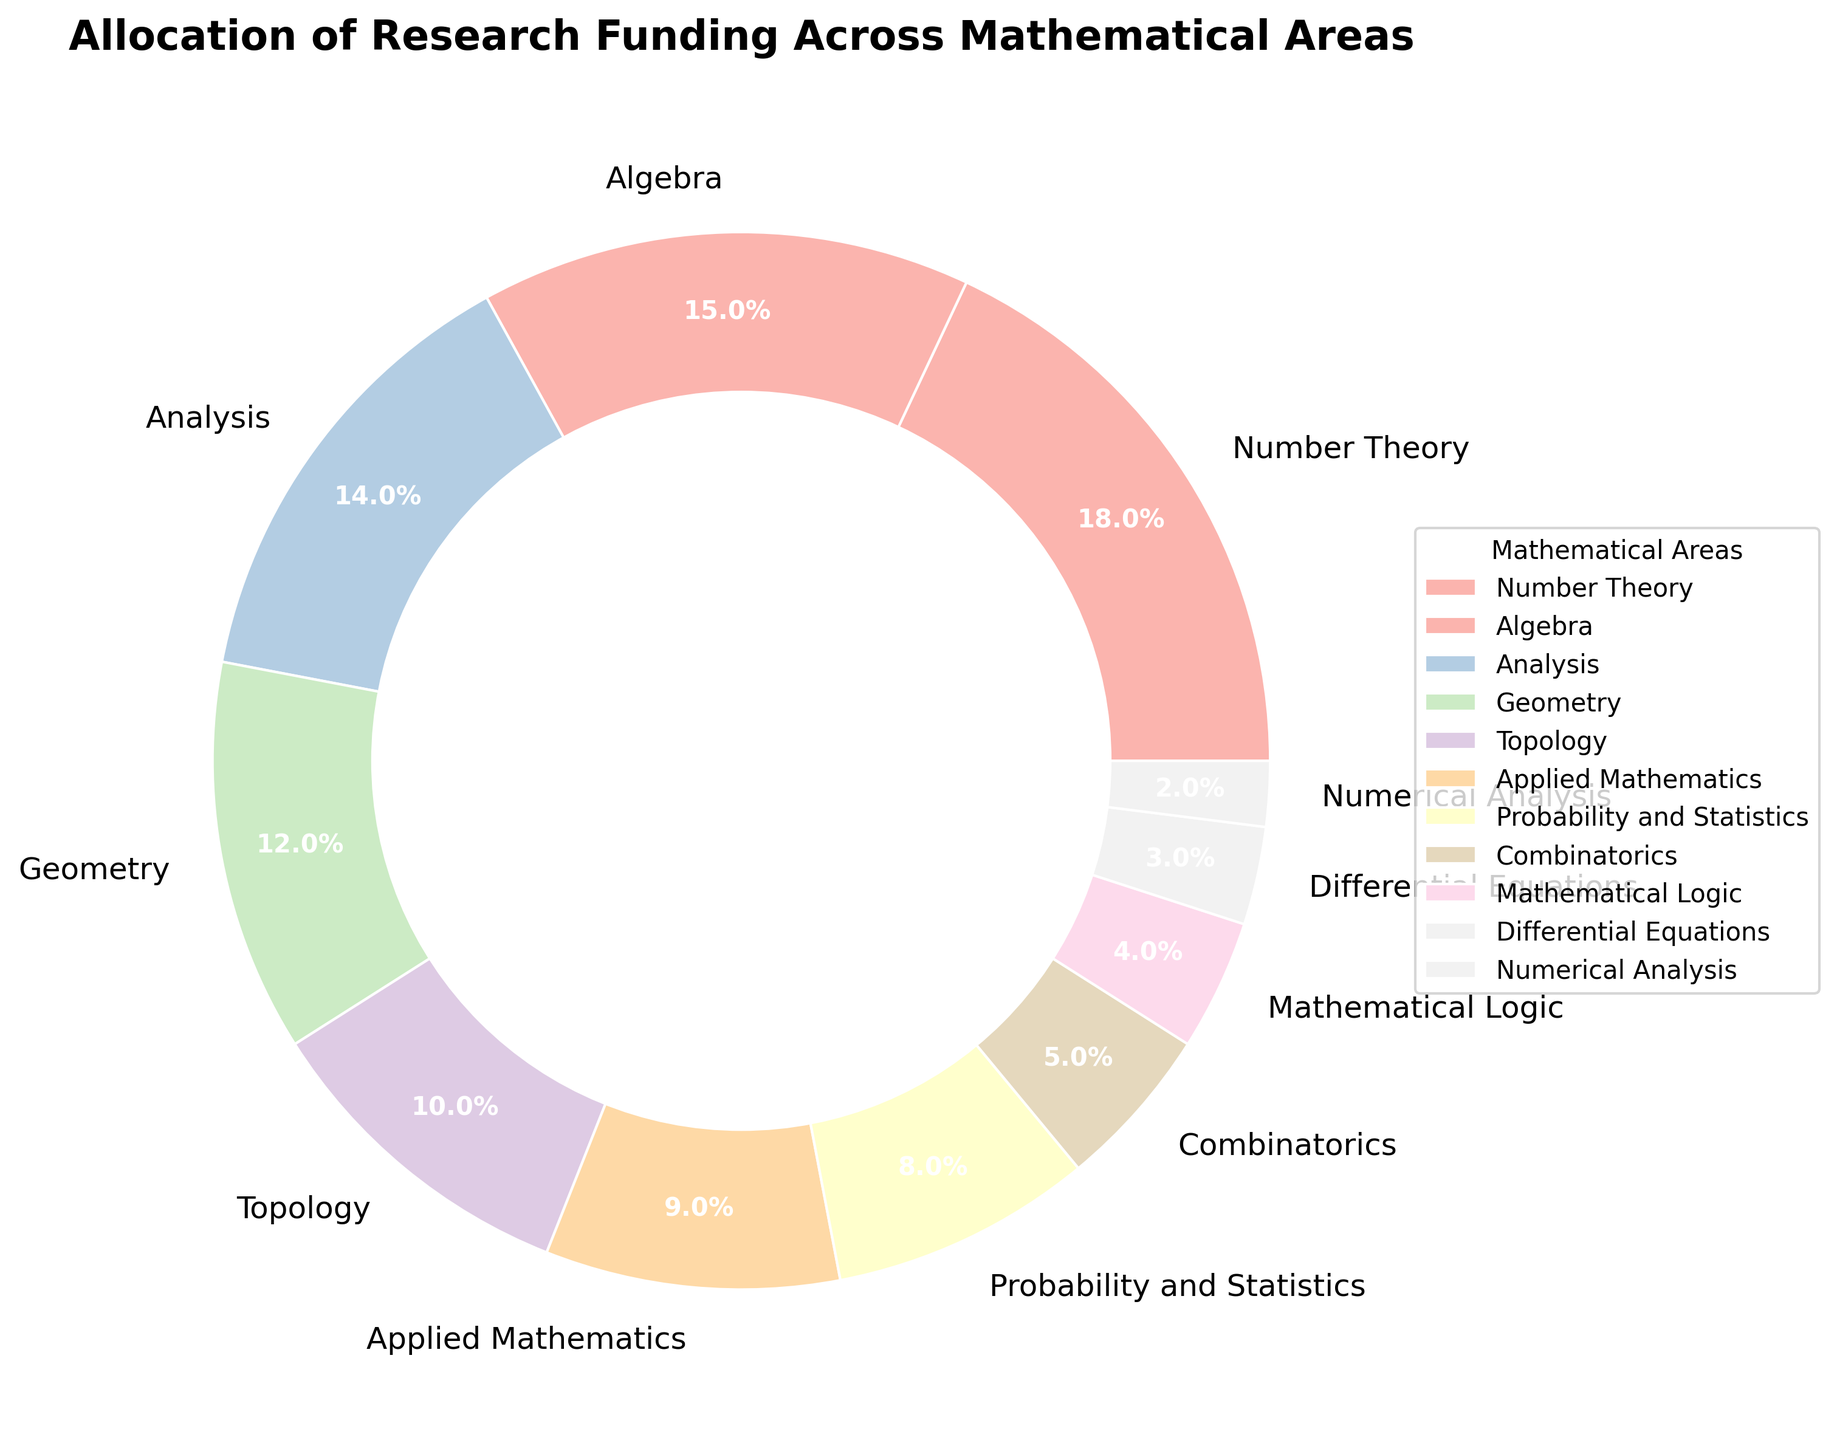What percentage of the funding is allocated to both Number Theory and Algebra combined? First, identify the funding percentages for Number Theory (18%) and Algebra (15%). Then, sum the two percentages: 18% + 15% = 33%.
Answer: 33% Which areas receive a smaller percentage of funding than Geometry? Find the funding percentage for Geometry, which is 12%. Identify areas with percentages less than 12%: Topology (10%), Applied Mathematics (9%), Probability and Statistics (8%), Combinatorics (5%), Mathematical Logic (4%), Differential Equations (3%), and Numerical Analysis (2%).
Answer: Topology, Applied Mathematics, Probability and Statistics, Combinatorics, Mathematical Logic, Differential Equations, Numerical Analysis Is the percentage allocated to Differential Equations greater than, less than, or equal to that allocated to Numerical Analysis? Compare the funding percentages of Differential Equations (3%) and Numerical Analysis (2%). Since 3% is greater than 2%, Differential Equations receive a greater percentage.
Answer: Greater than What is the total funding percentage for areas receiving less than 5% each? Identify areas with less than 5% funding: Combinatorics (5%), Mathematical Logic (4%), Differential Equations (3%), and Numerical Analysis (2%). Sum their percentages: 4% + 3% + 2% = 9%. Note that Combinatorics is excluded as it exactly equals 5%.
Answer: 9% Which area has the largest slice in the pie chart and what is its percentage? Examine the pie chart to identify the area with the largest slice. Number Theory stands out with the largest slice at 18%.
Answer: Number Theory, 18% How many areas receive at least 10% of the total funding? Identify areas with funding percentages of 10% or more: Number Theory (18%), Algebra (15%), Analysis (14%), and Geometry (12%). Count these areas to find there are 4 such areas.
Answer: 4 What is the difference in the funding percentages between Analysis and Topology? Analysis has a funding percentage of 14%, and Topology has 10%. Subtract Topology's percentage from Analysis's: 14% - 10% = 4%.
Answer: 4% Which area receives the least funding, and by how much is this less than the funding for Probability and Statistics? The area with the least funding is Numerical Analysis at 2%. The funding for Probability and Statistics is 8%. The difference is 8% - 2% = 6%.
Answer: Numerical Analysis, 6% What is the combined funding for Algebra, Analysis, and Geometry? Identify the funding percentages for Algebra (15%), Analysis (14%), and Geometry (12%). Sum these values: 15% + 14% + 12% = 41%.
Answer: 41% What portion of the total funding is allocated to Topology and Combinatorics together? Identify the funding percentages for Topology (10%) and Combinatorics (5%). Sum these percentages: 10% + 5% = 15%.
Answer: 15% 